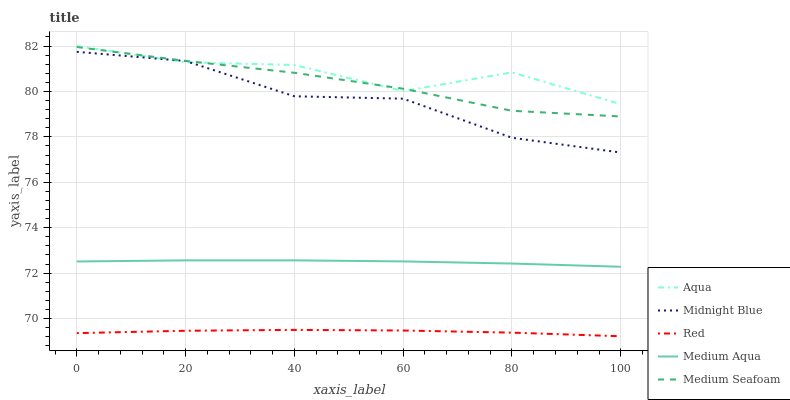Does Red have the minimum area under the curve?
Answer yes or no. Yes. Does Aqua have the maximum area under the curve?
Answer yes or no. Yes. Does Midnight Blue have the minimum area under the curve?
Answer yes or no. No. Does Midnight Blue have the maximum area under the curve?
Answer yes or no. No. Is Medium Aqua the smoothest?
Answer yes or no. Yes. Is Aqua the roughest?
Answer yes or no. Yes. Is Midnight Blue the smoothest?
Answer yes or no. No. Is Midnight Blue the roughest?
Answer yes or no. No. Does Red have the lowest value?
Answer yes or no. Yes. Does Midnight Blue have the lowest value?
Answer yes or no. No. Does Aqua have the highest value?
Answer yes or no. Yes. Does Midnight Blue have the highest value?
Answer yes or no. No. Is Red less than Medium Aqua?
Answer yes or no. Yes. Is Medium Aqua greater than Red?
Answer yes or no. Yes. Does Aqua intersect Midnight Blue?
Answer yes or no. Yes. Is Aqua less than Midnight Blue?
Answer yes or no. No. Is Aqua greater than Midnight Blue?
Answer yes or no. No. Does Red intersect Medium Aqua?
Answer yes or no. No. 